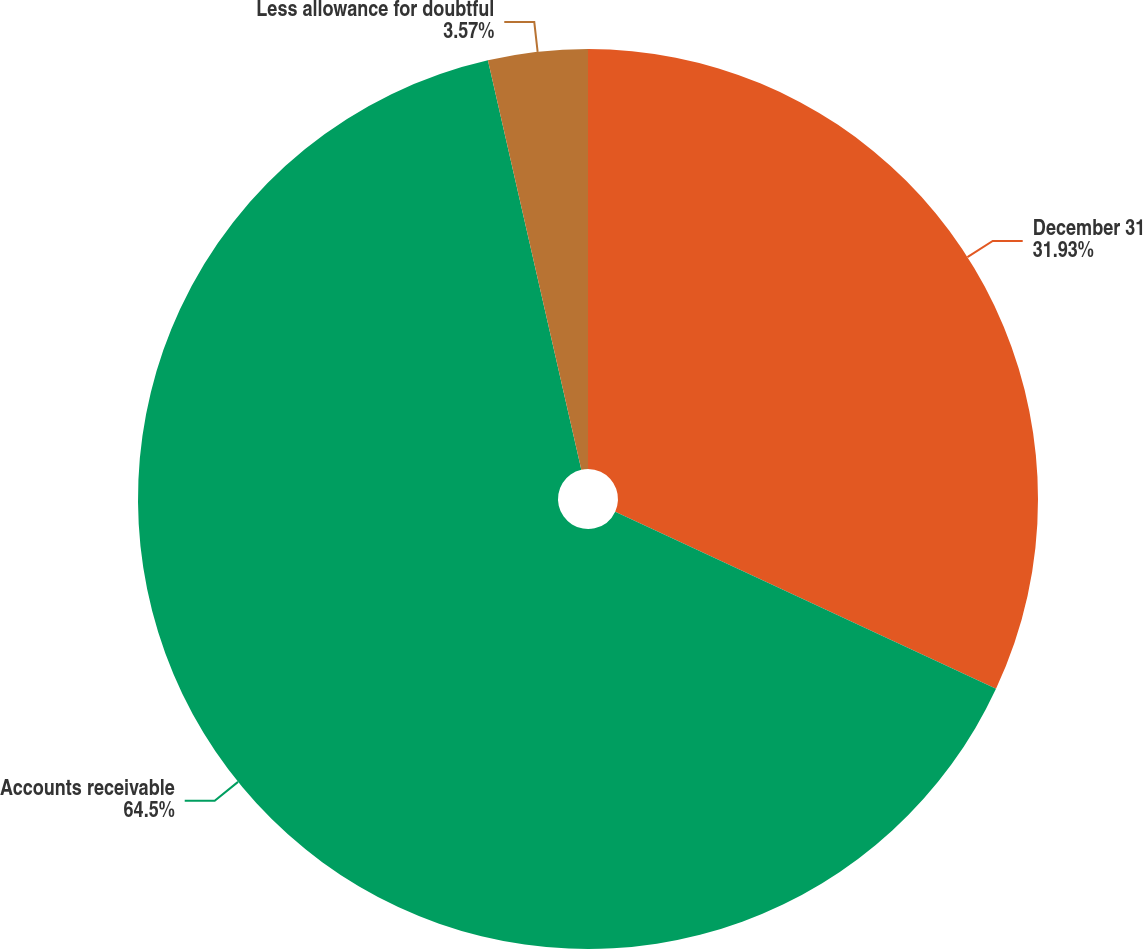Convert chart to OTSL. <chart><loc_0><loc_0><loc_500><loc_500><pie_chart><fcel>December 31<fcel>Accounts receivable<fcel>Less allowance for doubtful<nl><fcel>31.93%<fcel>64.5%<fcel>3.57%<nl></chart> 